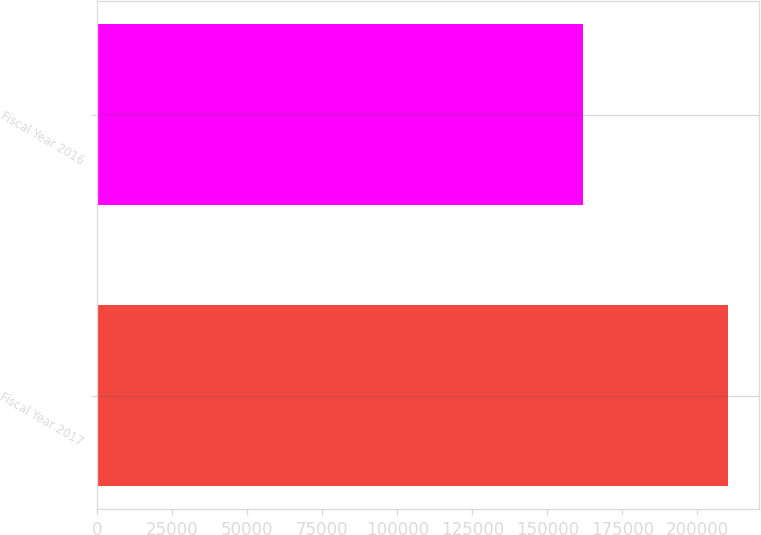Convert chart. <chart><loc_0><loc_0><loc_500><loc_500><bar_chart><fcel>Fiscal Year 2017<fcel>Fiscal Year 2016<nl><fcel>210120<fcel>161834<nl></chart> 